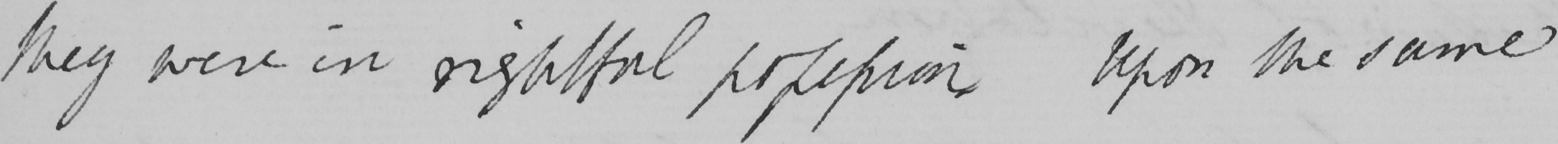Please provide the text content of this handwritten line. they were in rightful possession Upon the same 